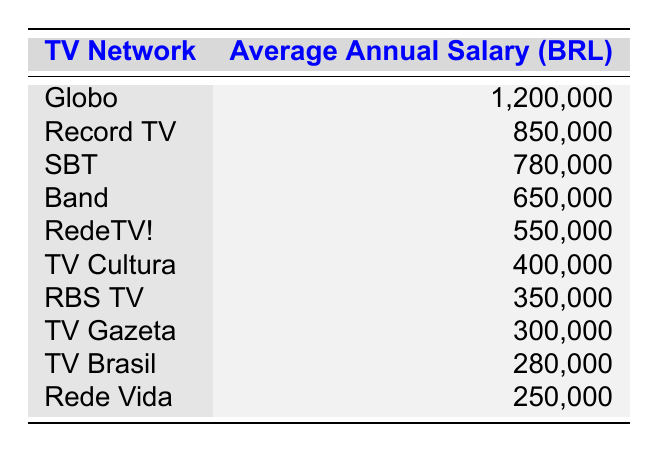What is the average annual salary of Globo? The table directly lists Globo's average annual salary as 1,200,000 BRL.
Answer: 1,200,000 BRL Which TV network has the lowest average salary? Looking at the data, Rede Vida has the lowest average salary listed at 250,000 BRL.
Answer: Rede Vida What is the difference in average salary between SBT and Band? SBT's average salary is 780,000 BRL, and Band's average is 650,000 BRL. The difference is 780,000 - 650,000 = 130,000 BRL.
Answer: 130,000 BRL Is RBS TV's average annual salary higher than TV Gazeta's? RBS TV has an average salary of 350,000 BRL, while TV Gazeta's average is 300,000 BRL. Since 350,000 > 300,000, the statement is true.
Answer: Yes What is the total average annual salary of the top three TV networks? The top three networks are Globo (1,200,000 BRL), Record TV (850,000 BRL), and SBT (780,000 BRL). Summing these, we find 1,200,000 + 850,000 + 780,000 = 2,830,000 BRL.
Answer: 2,830,000 BRL How many TV networks have an average salary above 500,000 BRL? The networks above 500,000 BRL are Globo, Record TV, SBT, and Band. That's a total of 4 networks.
Answer: 4 What average salary would make RBS TV rank in the top five networks? The fifth-highest salary is held by RedeTV! at 550,000 BRL. Therefore, RBS TV would need a salary above 550,000 BRL to be in the top five.
Answer: Above 550,000 BRL What is the average salary of the bottom three TV networks? The bottom three networks are TV Brasil (280,000 BRL), Rede Vida (250,000 BRL), and TV Gazeta (300,000 BRL). Their average is calculated as (280,000 + 250,000 + 300,000) / 3 = 276,667 BRL.
Answer: 276,667 BRL 